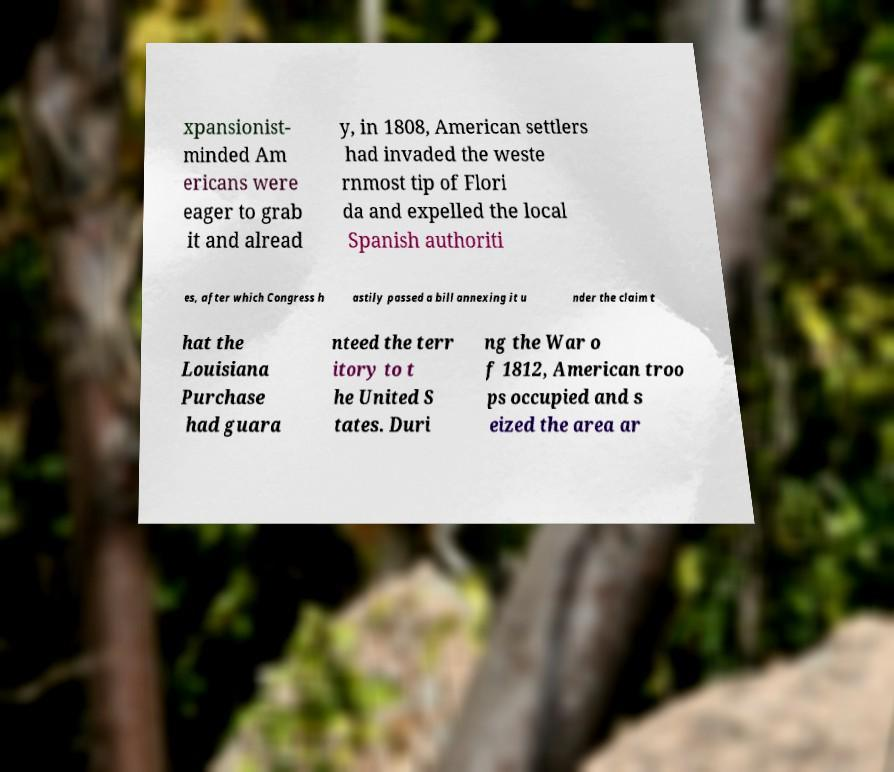Could you assist in decoding the text presented in this image and type it out clearly? xpansionist- minded Am ericans were eager to grab it and alread y, in 1808, American settlers had invaded the weste rnmost tip of Flori da and expelled the local Spanish authoriti es, after which Congress h astily passed a bill annexing it u nder the claim t hat the Louisiana Purchase had guara nteed the terr itory to t he United S tates. Duri ng the War o f 1812, American troo ps occupied and s eized the area ar 